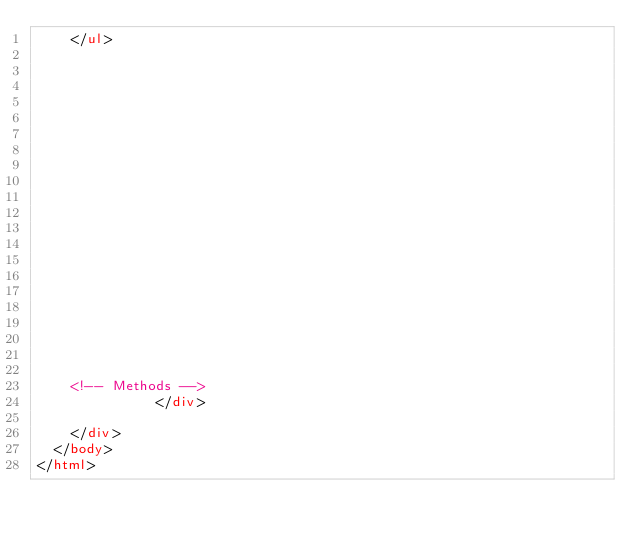<code> <loc_0><loc_0><loc_500><loc_500><_HTML_>    </ul>
  


  

  



  

    

    

    


    


    <!-- Methods -->
              </div>

    </div>
  </body>
</html></code> 